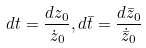Convert formula to latex. <formula><loc_0><loc_0><loc_500><loc_500>d t = \frac { d z _ { 0 } } { \dot { z } _ { 0 } } , d \bar { t } = \frac { d \bar { z } _ { 0 } } { \dot { \bar { z } } _ { 0 } }</formula> 